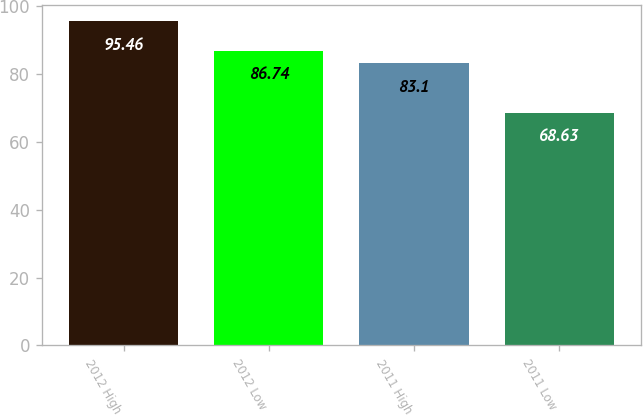<chart> <loc_0><loc_0><loc_500><loc_500><bar_chart><fcel>2012 High<fcel>2012 Low<fcel>2011 High<fcel>2011 Low<nl><fcel>95.46<fcel>86.74<fcel>83.1<fcel>68.63<nl></chart> 